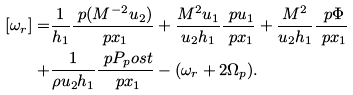Convert formula to latex. <formula><loc_0><loc_0><loc_500><loc_500>[ \omega _ { r } ] = & \frac { 1 } { h _ { 1 } } \frac { \ p ( M ^ { - 2 } u _ { 2 } ) } { \ p x _ { 1 } } + \frac { M ^ { 2 } u _ { 1 } } { u _ { 2 } h _ { 1 } } \frac { \ p u _ { 1 } } { \ p x _ { 1 } } + \frac { M ^ { 2 } } { u _ { 2 } h _ { 1 } } \frac { \ p \Phi } { \ p x _ { 1 } } \\ + & \frac { 1 } { \rho u _ { 2 } h _ { 1 } } \frac { \ p P _ { p } o s t } { \ p x _ { 1 } } - ( \omega _ { r } + 2 \Omega _ { p } ) .</formula> 